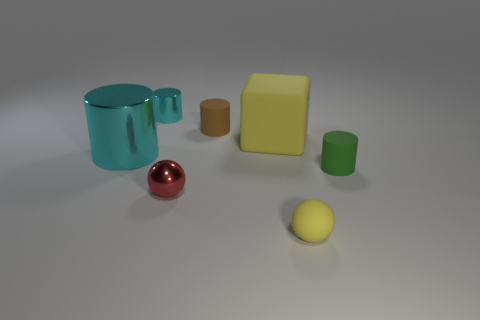Add 3 cyan metal cubes. How many objects exist? 10 Subtract all balls. How many objects are left? 5 Subtract 0 purple blocks. How many objects are left? 7 Subtract all small green balls. Subtract all brown rubber cylinders. How many objects are left? 6 Add 2 large yellow rubber things. How many large yellow rubber things are left? 3 Add 3 tiny red metal spheres. How many tiny red metal spheres exist? 4 